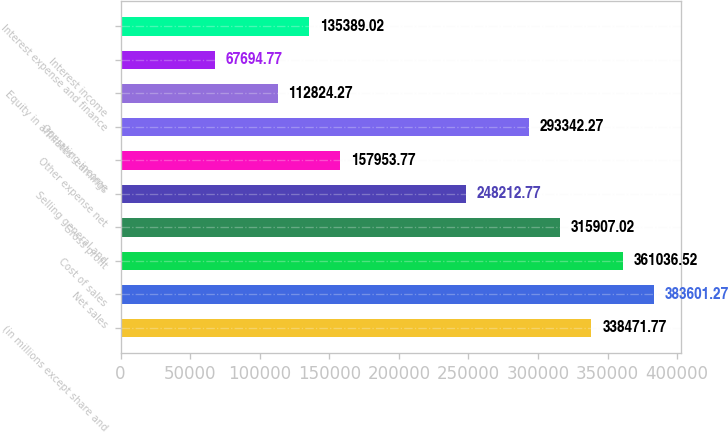Convert chart to OTSL. <chart><loc_0><loc_0><loc_500><loc_500><bar_chart><fcel>(in millions except share and<fcel>Net sales<fcel>Cost of sales<fcel>Gross profit<fcel>Selling general and<fcel>Other expense net<fcel>Operating income<fcel>Equity in affiliates' earnings<fcel>Interest income<fcel>Interest expense and finance<nl><fcel>338472<fcel>383601<fcel>361037<fcel>315907<fcel>248213<fcel>157954<fcel>293342<fcel>112824<fcel>67694.8<fcel>135389<nl></chart> 